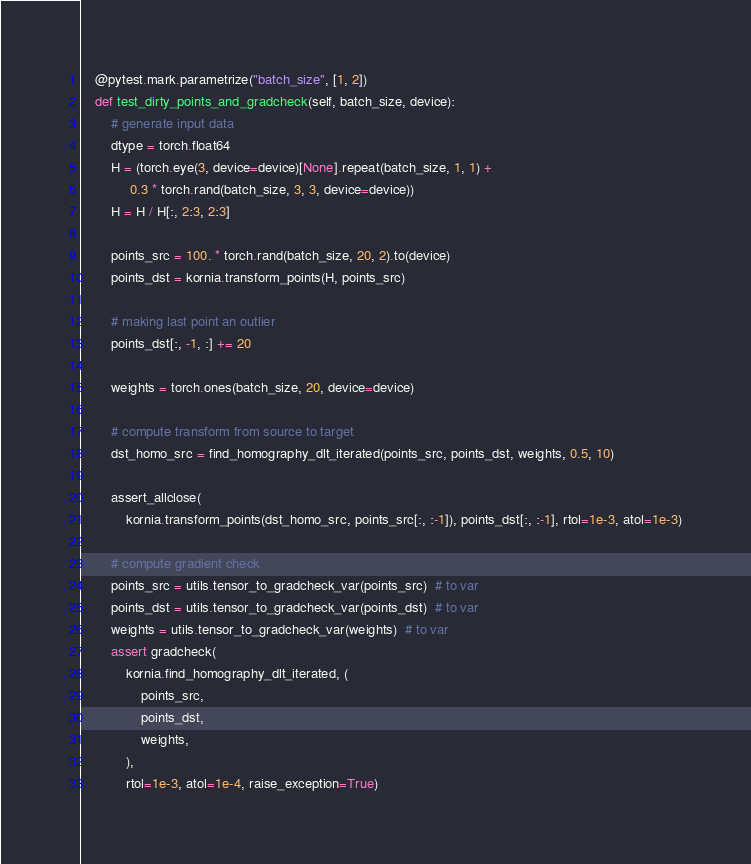<code> <loc_0><loc_0><loc_500><loc_500><_Python_>    @pytest.mark.parametrize("batch_size", [1, 2])
    def test_dirty_points_and_gradcheck(self, batch_size, device):
        # generate input data
        dtype = torch.float64
        H = (torch.eye(3, device=device)[None].repeat(batch_size, 1, 1) +
             0.3 * torch.rand(batch_size, 3, 3, device=device))
        H = H / H[:, 2:3, 2:3]

        points_src = 100. * torch.rand(batch_size, 20, 2).to(device)
        points_dst = kornia.transform_points(H, points_src)

        # making last point an outlier
        points_dst[:, -1, :] += 20

        weights = torch.ones(batch_size, 20, device=device)

        # compute transform from source to target
        dst_homo_src = find_homography_dlt_iterated(points_src, points_dst, weights, 0.5, 10)

        assert_allclose(
            kornia.transform_points(dst_homo_src, points_src[:, :-1]), points_dst[:, :-1], rtol=1e-3, atol=1e-3)

        # compute gradient check
        points_src = utils.tensor_to_gradcheck_var(points_src)  # to var
        points_dst = utils.tensor_to_gradcheck_var(points_dst)  # to var
        weights = utils.tensor_to_gradcheck_var(weights)  # to var
        assert gradcheck(
            kornia.find_homography_dlt_iterated, (
                points_src,
                points_dst,
                weights,
            ),
            rtol=1e-3, atol=1e-4, raise_exception=True)
</code> 